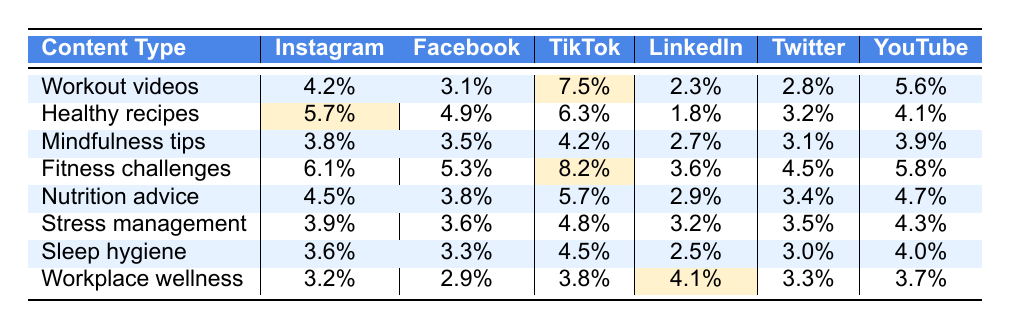What is the engagement rate for Workout videos on TikTok? The table shows that the engagement rate for Workout videos on TikTok is 7.5%.
Answer: 7.5% Which platform has the highest engagement rate for Nutrition advice? By examining the table, Nutrition advice has the highest engagement rate on Instagram at 4.5%.
Answer: Instagram What is the lowest engagement rate for Healthy recipes across all platforms? Looking at the table, the lowest engagement rate for Healthy recipes is on LinkedIn, which is 1.8%.
Answer: 1.8% Calculate the average engagement rate for Mindfulness tips across all platforms. The engagement rates for Mindfulness tips are 3.8%, 3.5%, 4.2%, 2.7%, 3.1%, and 3.9%. Adding them gives 21.2%, and dividing by 6 (the number of platforms) results in an average of 3.53%.
Answer: 3.53% Is the engagement rate for Fitness challenges on Instagram higher than that on Facebook? Yes, Fitness challenges have an engagement rate of 6.1% on Instagram and 5.3% on Facebook, thus the Instagram rate is higher.
Answer: Yes Which content type has the overall highest engagement rate across all platforms when considering the maximum value? By checking the maximum engagement rates, Fitness challenges on TikTok at 8.2% is the highest among all content types and platforms.
Answer: Fitness challenges Compare the engagement rates for Stress management on Twitter and YouTube. Which one is higher? Stress management's engagement rate is 3.5% on Twitter and 4.3% on YouTube, which means YouTube has a higher rate.
Answer: YouTube What is the total engagement rate for Sleep hygiene on Instagram and YouTube? The engagement rates for Sleep hygiene are 3.6% on Instagram and 4.0% on YouTube. Adding them gives a total of 7.6%.
Answer: 7.6% Are engagement rates for Workplace wellness higher on LinkedIn compared to other platforms? Yes, Workplace wellness has 4.1% on LinkedIn, which is higher than its rates on Instagram (3.2%), Facebook (2.9%), TikTok (3.8%), and Twitter (3.3%).
Answer: Yes What is the difference in engagement rates for Workout videos on TikTok and YouTube? The engagement rate for Workout videos is 7.5% on TikTok and 5.6% on YouTube. The difference is 7.5% - 5.6% = 1.9%.
Answer: 1.9% 